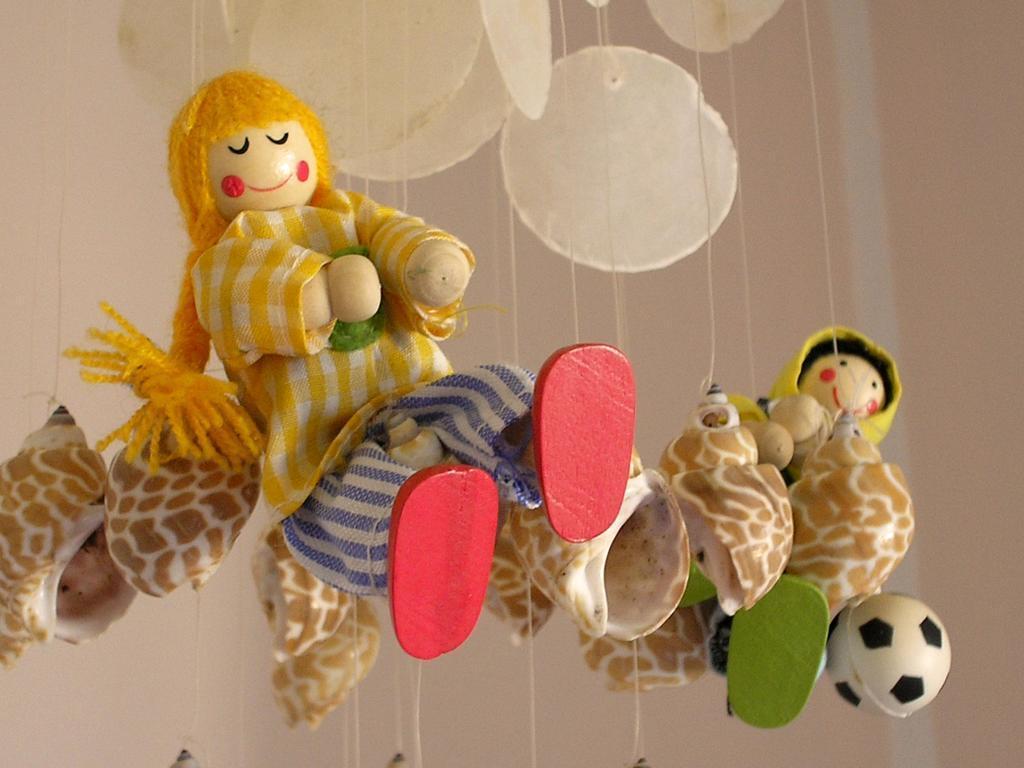Please provide a concise description of this image. In this picture we can see few toys and threads. 